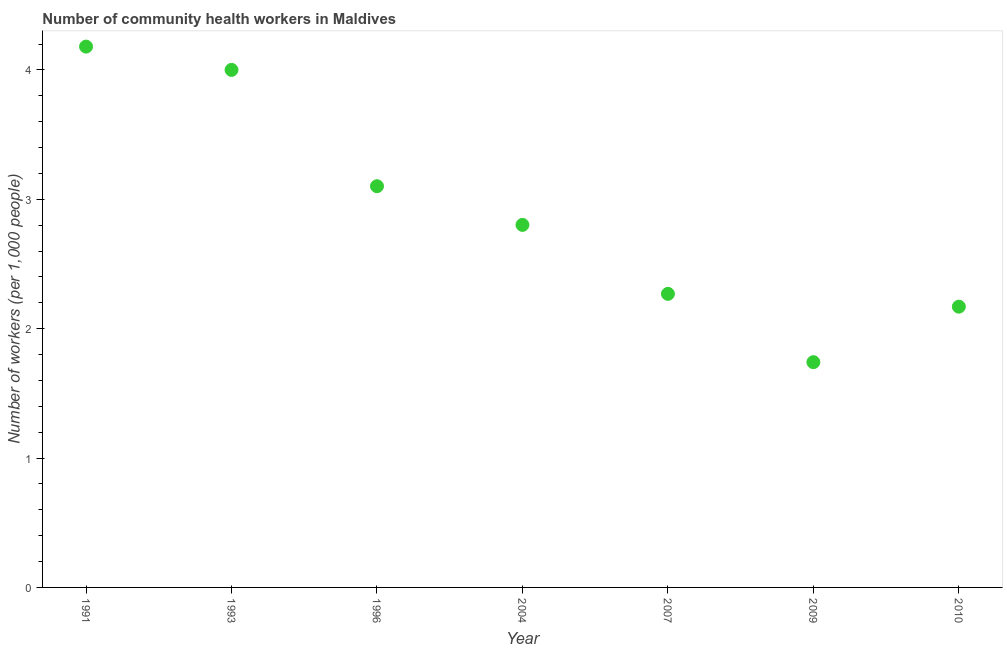What is the number of community health workers in 2007?
Ensure brevity in your answer.  2.27. Across all years, what is the maximum number of community health workers?
Ensure brevity in your answer.  4.18. Across all years, what is the minimum number of community health workers?
Make the answer very short. 1.74. What is the sum of the number of community health workers?
Your answer should be compact. 20.26. What is the difference between the number of community health workers in 1991 and 2010?
Provide a short and direct response. 2.01. What is the average number of community health workers per year?
Ensure brevity in your answer.  2.89. What is the median number of community health workers?
Keep it short and to the point. 2.8. What is the ratio of the number of community health workers in 2009 to that in 2010?
Keep it short and to the point. 0.8. Is the number of community health workers in 1996 less than that in 2007?
Offer a very short reply. No. What is the difference between the highest and the second highest number of community health workers?
Provide a short and direct response. 0.18. Is the sum of the number of community health workers in 1991 and 1993 greater than the maximum number of community health workers across all years?
Your answer should be very brief. Yes. What is the difference between the highest and the lowest number of community health workers?
Give a very brief answer. 2.44. In how many years, is the number of community health workers greater than the average number of community health workers taken over all years?
Provide a succinct answer. 3. Does the number of community health workers monotonically increase over the years?
Your answer should be compact. No. How many years are there in the graph?
Your answer should be compact. 7. What is the difference between two consecutive major ticks on the Y-axis?
Your answer should be compact. 1. Are the values on the major ticks of Y-axis written in scientific E-notation?
Your response must be concise. No. What is the title of the graph?
Offer a terse response. Number of community health workers in Maldives. What is the label or title of the Y-axis?
Give a very brief answer. Number of workers (per 1,0 people). What is the Number of workers (per 1,000 people) in 1991?
Offer a terse response. 4.18. What is the Number of workers (per 1,000 people) in 1996?
Make the answer very short. 3.1. What is the Number of workers (per 1,000 people) in 2004?
Keep it short and to the point. 2.8. What is the Number of workers (per 1,000 people) in 2007?
Your answer should be very brief. 2.27. What is the Number of workers (per 1,000 people) in 2009?
Your answer should be compact. 1.74. What is the Number of workers (per 1,000 people) in 2010?
Provide a succinct answer. 2.17. What is the difference between the Number of workers (per 1,000 people) in 1991 and 1993?
Ensure brevity in your answer.  0.18. What is the difference between the Number of workers (per 1,000 people) in 1991 and 1996?
Provide a short and direct response. 1.08. What is the difference between the Number of workers (per 1,000 people) in 1991 and 2004?
Keep it short and to the point. 1.38. What is the difference between the Number of workers (per 1,000 people) in 1991 and 2007?
Your answer should be compact. 1.91. What is the difference between the Number of workers (per 1,000 people) in 1991 and 2009?
Keep it short and to the point. 2.44. What is the difference between the Number of workers (per 1,000 people) in 1991 and 2010?
Keep it short and to the point. 2.01. What is the difference between the Number of workers (per 1,000 people) in 1993 and 1996?
Provide a short and direct response. 0.9. What is the difference between the Number of workers (per 1,000 people) in 1993 and 2004?
Offer a terse response. 1.2. What is the difference between the Number of workers (per 1,000 people) in 1993 and 2007?
Your response must be concise. 1.73. What is the difference between the Number of workers (per 1,000 people) in 1993 and 2009?
Make the answer very short. 2.26. What is the difference between the Number of workers (per 1,000 people) in 1993 and 2010?
Offer a very short reply. 1.83. What is the difference between the Number of workers (per 1,000 people) in 1996 and 2004?
Offer a terse response. 0.3. What is the difference between the Number of workers (per 1,000 people) in 1996 and 2007?
Keep it short and to the point. 0.83. What is the difference between the Number of workers (per 1,000 people) in 1996 and 2009?
Ensure brevity in your answer.  1.36. What is the difference between the Number of workers (per 1,000 people) in 2004 and 2007?
Your answer should be compact. 0.53. What is the difference between the Number of workers (per 1,000 people) in 2004 and 2009?
Your answer should be compact. 1.06. What is the difference between the Number of workers (per 1,000 people) in 2004 and 2010?
Keep it short and to the point. 0.63. What is the difference between the Number of workers (per 1,000 people) in 2007 and 2009?
Ensure brevity in your answer.  0.53. What is the difference between the Number of workers (per 1,000 people) in 2007 and 2010?
Keep it short and to the point. 0.1. What is the difference between the Number of workers (per 1,000 people) in 2009 and 2010?
Provide a succinct answer. -0.43. What is the ratio of the Number of workers (per 1,000 people) in 1991 to that in 1993?
Offer a terse response. 1.04. What is the ratio of the Number of workers (per 1,000 people) in 1991 to that in 1996?
Provide a short and direct response. 1.35. What is the ratio of the Number of workers (per 1,000 people) in 1991 to that in 2004?
Offer a very short reply. 1.49. What is the ratio of the Number of workers (per 1,000 people) in 1991 to that in 2007?
Offer a very short reply. 1.84. What is the ratio of the Number of workers (per 1,000 people) in 1991 to that in 2009?
Provide a succinct answer. 2.4. What is the ratio of the Number of workers (per 1,000 people) in 1991 to that in 2010?
Provide a short and direct response. 1.93. What is the ratio of the Number of workers (per 1,000 people) in 1993 to that in 1996?
Provide a short and direct response. 1.29. What is the ratio of the Number of workers (per 1,000 people) in 1993 to that in 2004?
Offer a terse response. 1.43. What is the ratio of the Number of workers (per 1,000 people) in 1993 to that in 2007?
Your response must be concise. 1.76. What is the ratio of the Number of workers (per 1,000 people) in 1993 to that in 2009?
Your response must be concise. 2.3. What is the ratio of the Number of workers (per 1,000 people) in 1993 to that in 2010?
Your answer should be very brief. 1.84. What is the ratio of the Number of workers (per 1,000 people) in 1996 to that in 2004?
Offer a terse response. 1.11. What is the ratio of the Number of workers (per 1,000 people) in 1996 to that in 2007?
Your answer should be compact. 1.37. What is the ratio of the Number of workers (per 1,000 people) in 1996 to that in 2009?
Give a very brief answer. 1.78. What is the ratio of the Number of workers (per 1,000 people) in 1996 to that in 2010?
Provide a short and direct response. 1.43. What is the ratio of the Number of workers (per 1,000 people) in 2004 to that in 2007?
Give a very brief answer. 1.24. What is the ratio of the Number of workers (per 1,000 people) in 2004 to that in 2009?
Offer a very short reply. 1.61. What is the ratio of the Number of workers (per 1,000 people) in 2004 to that in 2010?
Your answer should be very brief. 1.29. What is the ratio of the Number of workers (per 1,000 people) in 2007 to that in 2009?
Provide a succinct answer. 1.3. What is the ratio of the Number of workers (per 1,000 people) in 2007 to that in 2010?
Make the answer very short. 1.05. What is the ratio of the Number of workers (per 1,000 people) in 2009 to that in 2010?
Your answer should be very brief. 0.8. 